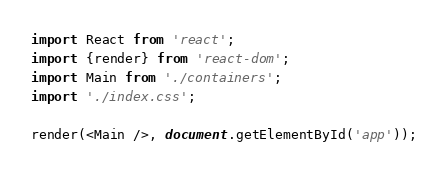Convert code to text. <code><loc_0><loc_0><loc_500><loc_500><_JavaScript_>import React from 'react';
import {render} from 'react-dom';
import Main from './containers';
import './index.css';

render(<Main />, document.getElementById('app'));
</code> 